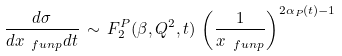Convert formula to latex. <formula><loc_0><loc_0><loc_500><loc_500>\frac { d \sigma } { d x _ { \ f u n p } d t } \, \sim \, F _ { 2 } ^ { P } ( \beta , Q ^ { 2 } , t ) \, \left ( \frac { 1 } { x _ { \ f u n p } } \right ) ^ { 2 \alpha _ { P } ( t ) - 1 }</formula> 